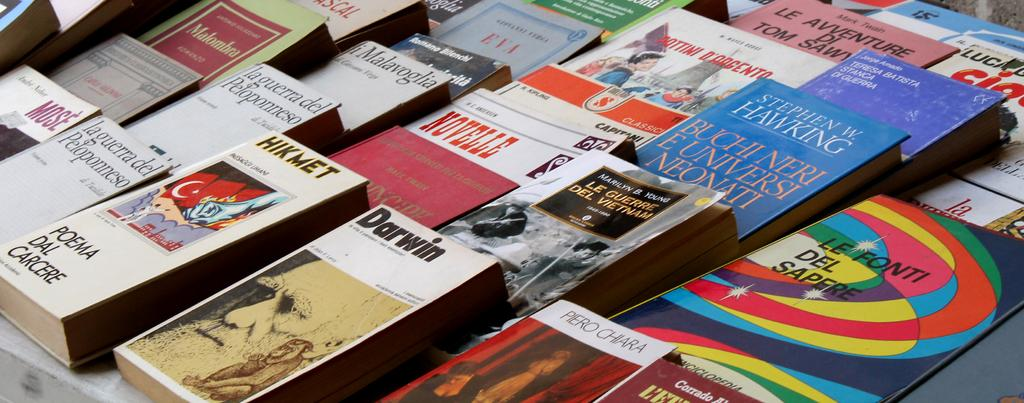<image>
Describe the image concisely. Books that are stacked beside each other about  Darwin and others 